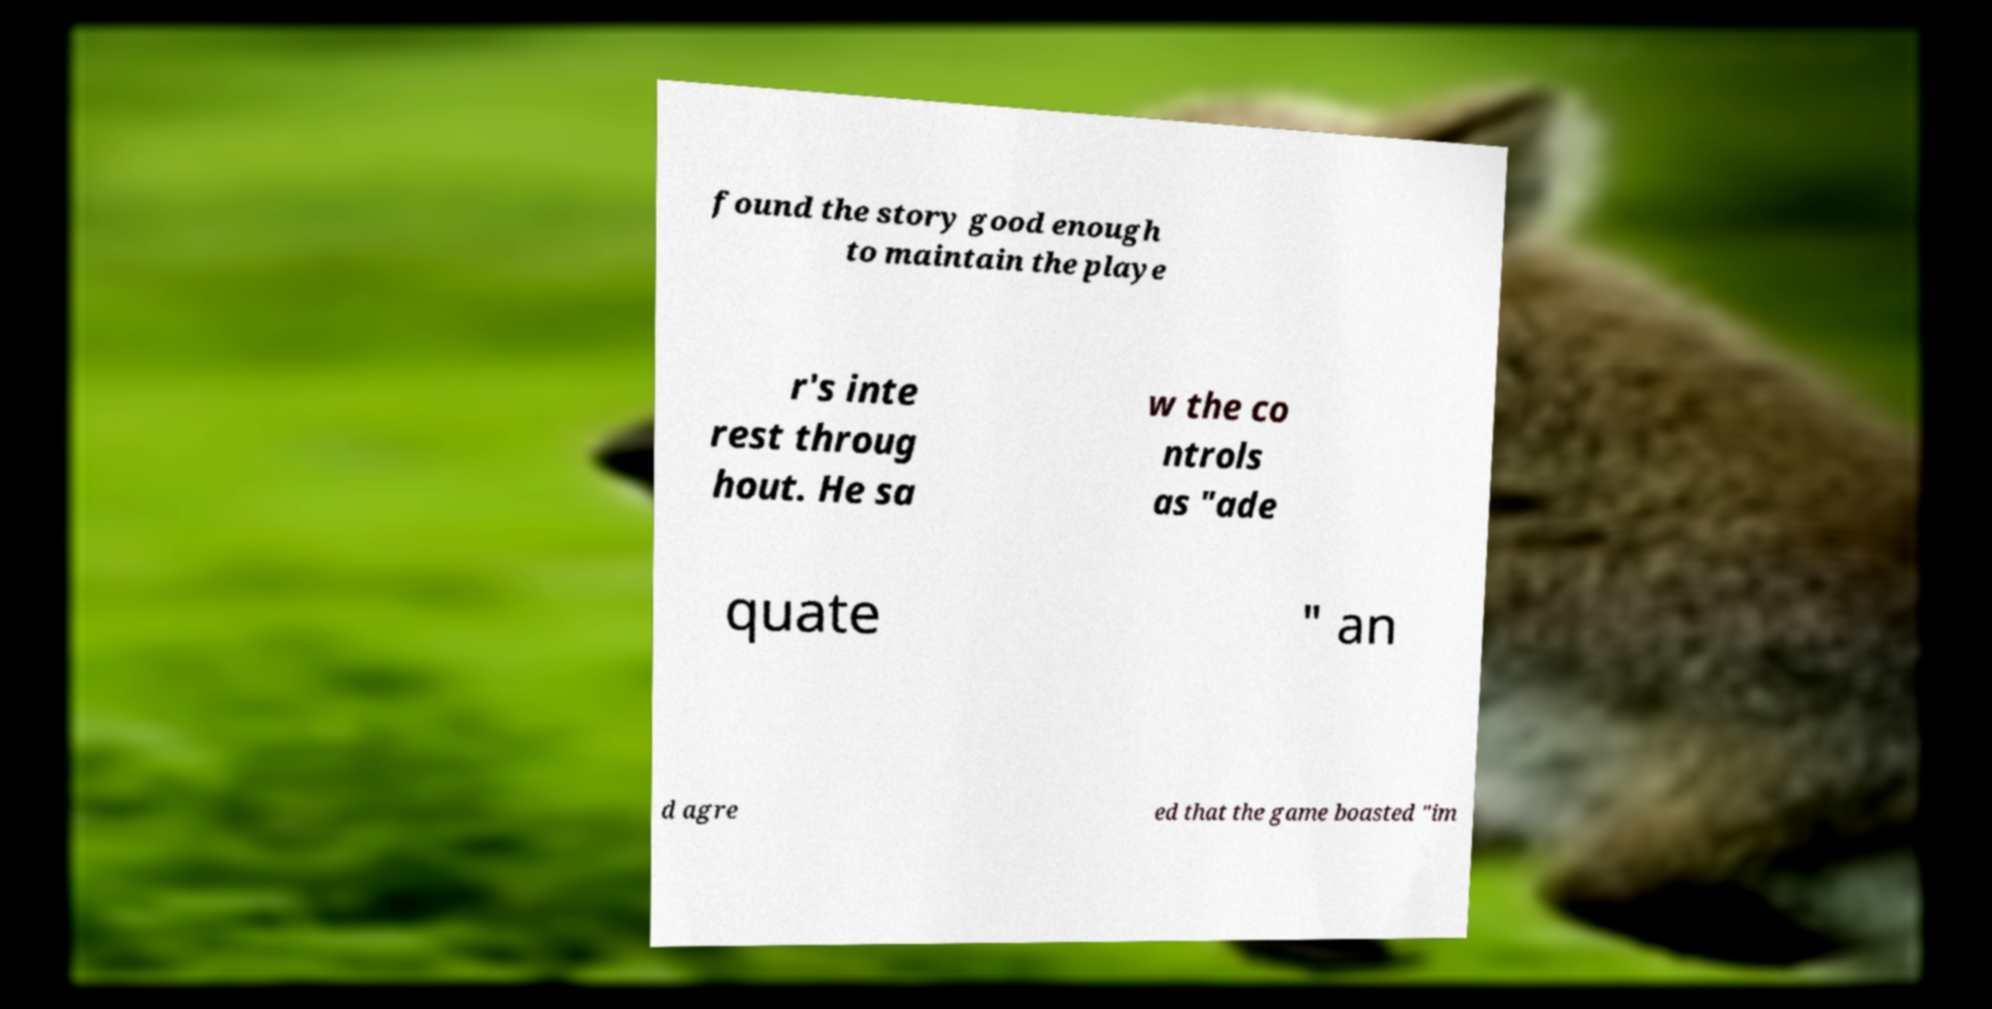Can you read and provide the text displayed in the image?This photo seems to have some interesting text. Can you extract and type it out for me? found the story good enough to maintain the playe r's inte rest throug hout. He sa w the co ntrols as "ade quate " an d agre ed that the game boasted "im 